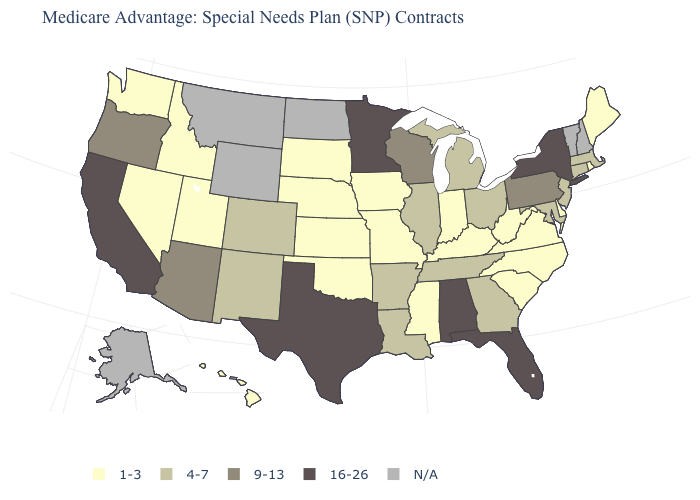Does Indiana have the lowest value in the MidWest?
Answer briefly. Yes. Does the map have missing data?
Write a very short answer. Yes. Among the states that border Nevada , does Idaho have the lowest value?
Keep it brief. Yes. What is the value of Alabama?
Be succinct. 16-26. Does the map have missing data?
Short answer required. Yes. Does the map have missing data?
Be succinct. Yes. What is the lowest value in the Northeast?
Write a very short answer. 1-3. Name the states that have a value in the range 9-13?
Quick response, please. Arizona, Oregon, Pennsylvania, Wisconsin. Which states have the highest value in the USA?
Be succinct. Alabama, California, Florida, Minnesota, New York, Texas. Does Rhode Island have the lowest value in the Northeast?
Concise answer only. Yes. What is the value of West Virginia?
Keep it brief. 1-3. Name the states that have a value in the range N/A?
Short answer required. Alaska, Montana, North Dakota, New Hampshire, Vermont, Wyoming. Name the states that have a value in the range 4-7?
Give a very brief answer. Arkansas, Colorado, Connecticut, Georgia, Illinois, Louisiana, Massachusetts, Maryland, Michigan, New Jersey, New Mexico, Ohio, Tennessee. 